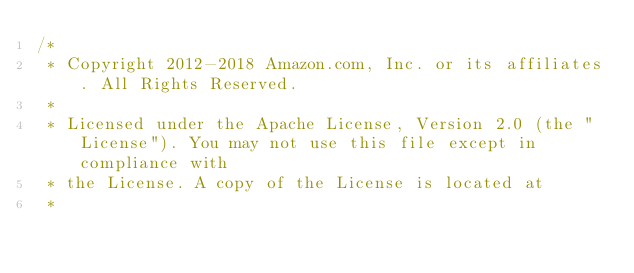Convert code to text. <code><loc_0><loc_0><loc_500><loc_500><_Java_>/*
 * Copyright 2012-2018 Amazon.com, Inc. or its affiliates. All Rights Reserved.
 * 
 * Licensed under the Apache License, Version 2.0 (the "License"). You may not use this file except in compliance with
 * the License. A copy of the License is located at
 * </code> 